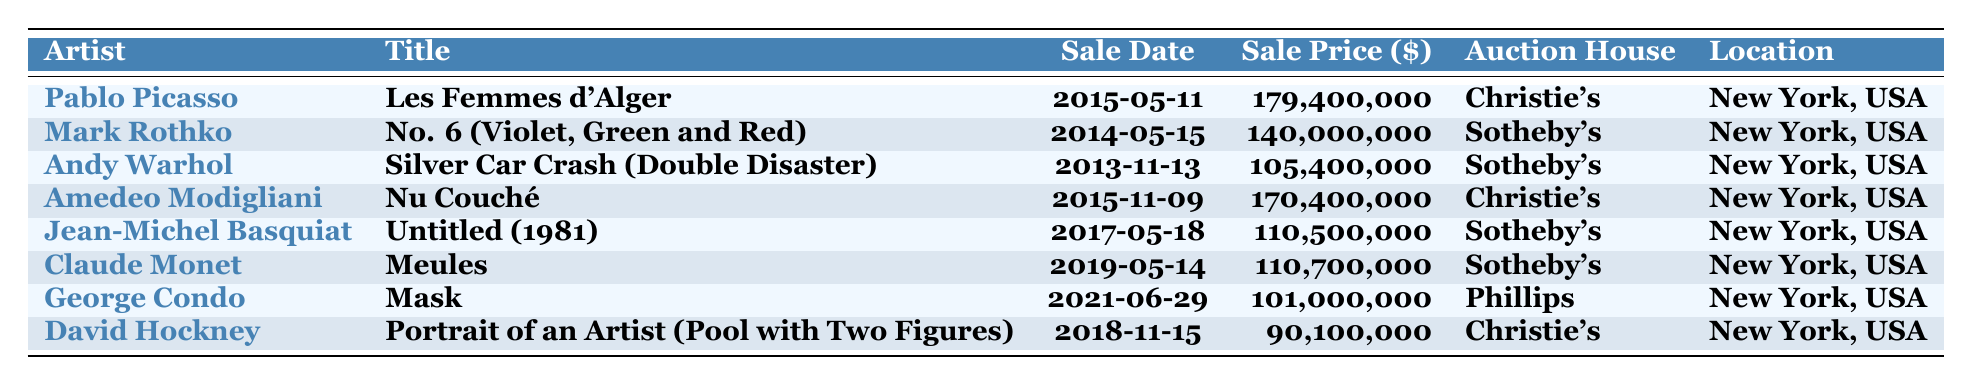What is the highest sale price for an artwork listed in the table? The highest sale price can be found by scanning the "Sale Price ($)" column for the maximum value. The highest sale price is 179,400,000 for "Les Femmes d'Alger" by Pablo Picasso.
Answer: 179,400,000 Which artist has their artwork sold in 2019? By looking at the "Sale Date" column, the only artwork sold in 2019 is "Meules" by Claude Monet.
Answer: Claude Monet What is the total sale price of all artworks by Sotheby's? To find the total, identify all artworks sold at Sotheby's and sum their sale prices: 140,000,000 (Mark Rothko) + 105,400,000 (Andy Warhol) + 110,500,000 (Jean-Michel Basquiat) + 110,700,000 (Claude Monet) = 466,600,000.
Answer: 466,600,000 How many artworks were sold at Christie's? Count the number of entries listed under Christie's in the "Auction House" column. There are 3 artworks: "Les Femmes d'Alger," "Nu Couché," and "Portrait of an Artist."
Answer: 3 Was any artwork sold for more than 150 million dollars? Check the "Sale Price ($)" column for any amount greater than 150 million. "Les Femmes d'Alger" at 179,400,000 and "Nu Couché" at 170,400,000 qualify.
Answer: Yes What is the average sale price of the artworks sold in 2015? Identify the artworks sold in 2015: "Les Femmes d'Alger" (179,400,000) and "Nu Couché" (170,400,000). The total is 179,400,000 + 170,400,000 = 349,800,000. There are 2 artworks, so the average is 349,800,000 / 2 = 174,900,000.
Answer: 174,900,000 Which artist sold their work for less than 100 million dollars? Check the "Sale Price ($)" column for entries below 100 million dollars. "Portrait of an Artist (Pool with Two Figures)" by David Hockney at 90,100,000 is the only one.
Answer: David Hockney What was the average sale price across all artworks listed in the table? Sum all sale prices: 179,400,000 + 140,000,000 + 105,400,000 + 170,400,000 + 110,500,000 + 110,700,000 + 101,000,000 + 90,100,000 = 1,007,500,000. There are 8 artworks, so the average is 1,007,500,000 / 8 = 125,937,500.
Answer: 125,937,500 Is there any artwork listed that was sold in 2021? Check the "Sale Date" column for any entry from 2021. There is "Mask" by George Condo sold on 2021-06-29.
Answer: Yes What is the difference in sale price between the most expensive and the least expensive artwork in the table? Identify the highest (179,400,000) and lowest sale prices (90,100,000) then calculate the difference: 179,400,000 - 90,100,000 = 89,300,000.
Answer: 89,300,000 